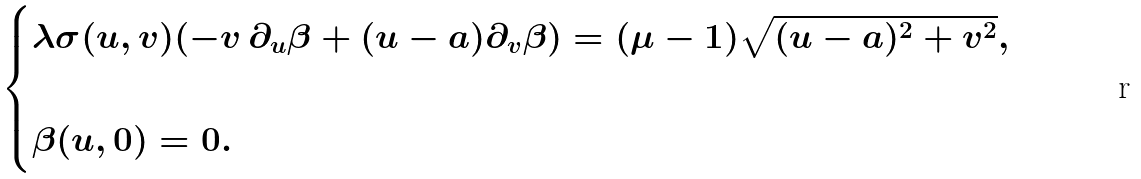<formula> <loc_0><loc_0><loc_500><loc_500>\begin{cases} \lambda \sigma ( u , v ) ( - v \, \partial _ { u } \beta + ( u - a ) \partial _ { v } \beta ) = ( \mu - 1 ) \sqrt { ( u - a ) ^ { 2 } + v ^ { 2 } } , & \\ \\ \beta ( u , 0 ) = 0 . & \end{cases}</formula> 